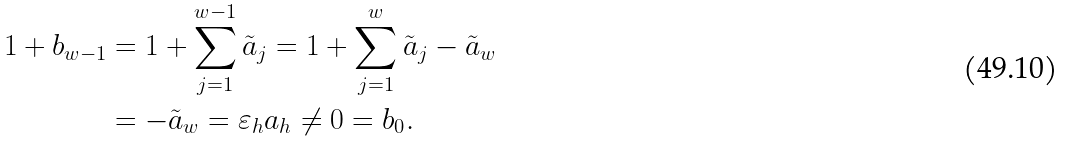Convert formula to latex. <formula><loc_0><loc_0><loc_500><loc_500>1 + b _ { w - 1 } & = 1 + \sum _ { j = 1 } ^ { w - 1 } \tilde { a } _ { j } = 1 + \sum _ { j = 1 } ^ { w } \tilde { a } _ { j } - \tilde { a } _ { w } \\ & = - \tilde { a } _ { w } = \varepsilon _ { h } a _ { h } \neq 0 = b _ { 0 } .</formula> 